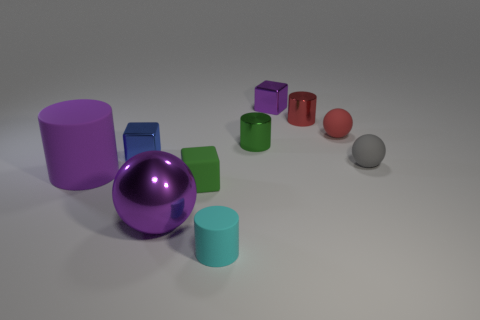Subtract all small blue blocks. How many blocks are left? 2 Subtract all gray balls. How many balls are left? 2 Subtract 1 blocks. How many blocks are left? 2 Subtract all cylinders. How many objects are left? 6 Subtract 0 cyan blocks. How many objects are left? 10 Subtract all brown balls. Subtract all gray cylinders. How many balls are left? 3 Subtract all large purple objects. Subtract all red shiny objects. How many objects are left? 7 Add 7 cyan objects. How many cyan objects are left? 8 Add 7 large gray matte cylinders. How many large gray matte cylinders exist? 7 